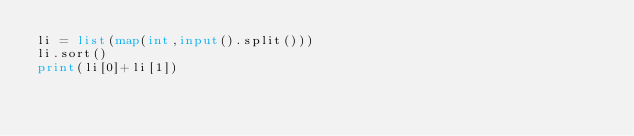<code> <loc_0><loc_0><loc_500><loc_500><_Python_>li = list(map(int,input().split()))
li.sort()
print(li[0]+li[1])</code> 